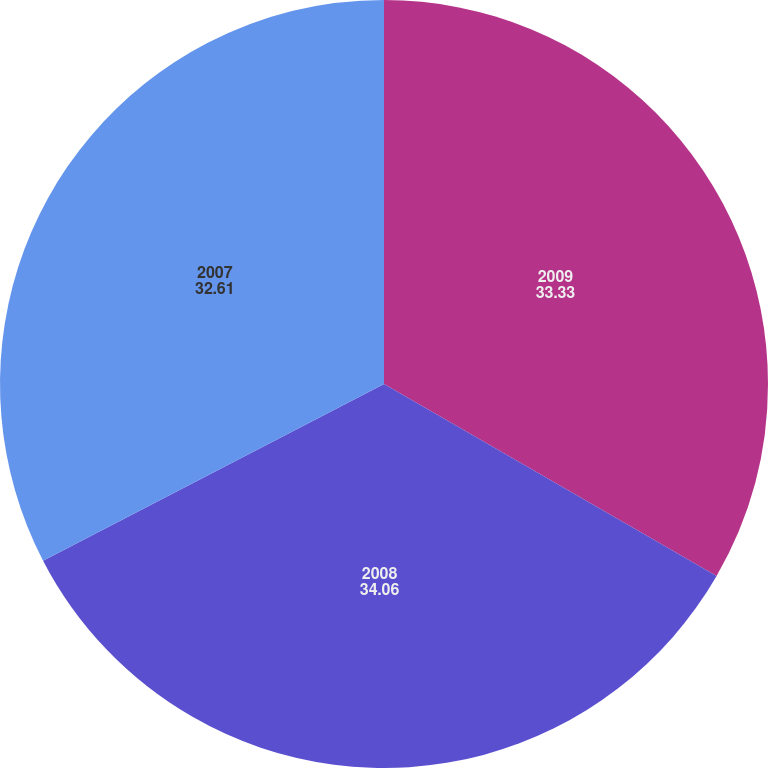Convert chart to OTSL. <chart><loc_0><loc_0><loc_500><loc_500><pie_chart><fcel>2009<fcel>2008<fcel>2007<nl><fcel>33.33%<fcel>34.06%<fcel>32.61%<nl></chart> 